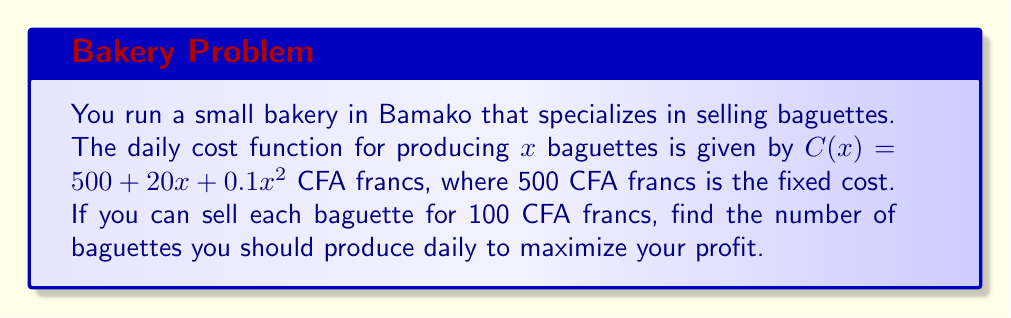Can you answer this question? Let's approach this step-by-step using differential calculus:

1) First, let's define the profit function. Profit is revenue minus cost:
   
   $P(x) = R(x) - C(x)$

2) Revenue is the number of baguettes sold multiplied by the price per baguette:
   
   $R(x) = 100x$

3) The cost function is given:
   
   $C(x) = 500 + 20x + 0.1x^2$

4) Therefore, the profit function is:
   
   $P(x) = 100x - (500 + 20x + 0.1x^2)$
   $P(x) = 100x - 500 - 20x - 0.1x^2$
   $P(x) = 80x - 500 - 0.1x^2$

5) To find the maximum profit, we need to find where the derivative of $P(x)$ equals zero:
   
   $$\frac{dP}{dx} = 80 - 0.2x$$

6) Set this equal to zero and solve for x:
   
   $80 - 0.2x = 0$
   $80 = 0.2x$
   $x = 400$

7) To confirm this is a maximum (not a minimum), check the second derivative:
   
   $$\frac{d^2P}{dx^2} = -0.2$$

   This is negative, confirming we have found a maximum.

Therefore, to maximize profit, you should produce 400 baguettes daily.
Answer: 400 baguettes 